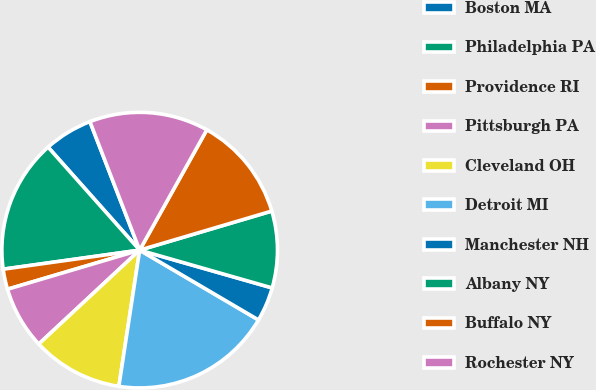Convert chart to OTSL. <chart><loc_0><loc_0><loc_500><loc_500><pie_chart><fcel>Boston MA<fcel>Philadelphia PA<fcel>Providence RI<fcel>Pittsburgh PA<fcel>Cleveland OH<fcel>Detroit MI<fcel>Manchester NH<fcel>Albany NY<fcel>Buffalo NY<fcel>Rochester NY<nl><fcel>5.69%<fcel>15.64%<fcel>2.37%<fcel>7.35%<fcel>10.66%<fcel>18.96%<fcel>4.03%<fcel>9.0%<fcel>12.32%<fcel>13.98%<nl></chart> 